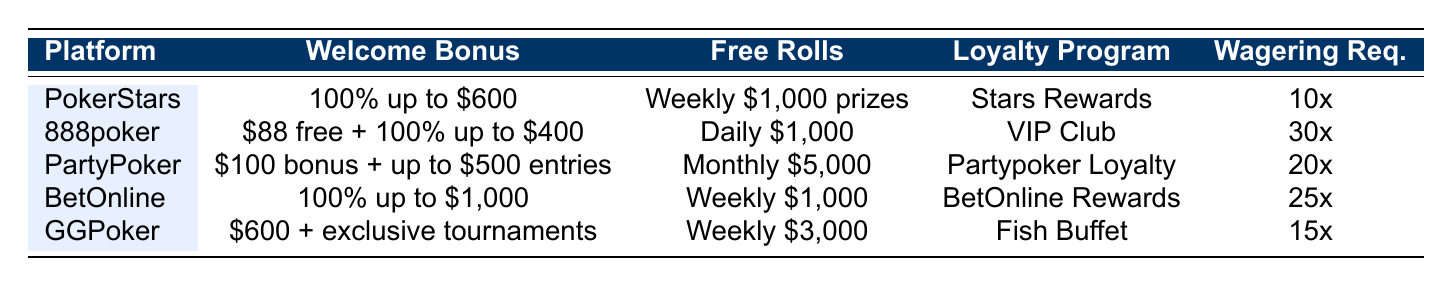What is the welcome bonus offered by GGPoker? The table states that GGPoker offers a welcome bonus of "$600 + exclusive tournaments."
Answer: $600 + exclusive tournaments Which platform has the lowest wagering requirement? By comparing the wagering requirements in the table, PokerStars has the lowest at "10x."
Answer: PokerStars Does PartyPoker offer daily free rolls? The table indicates that PartyPoker offers a "Monthly $5,000 tournament" for free rolls, meaning it does not provide daily free rolls.
Answer: No What is the total potential welcome bonus of 888poker? The welcome bonus for 888poker consists of "$88 free upon registration + 100% up to $400," which sums up to $488 as the maximum total bonus upon deposit.
Answer: $488 Which platform has the best loyalty program according to the naming? The table lists several loyalty programs, but it does not quantify their value or performance. However, the unique name "Fish Buffet" for GGPoker might imply an appealing offer.
Answer: GGPoker What is the maximum bonus amount you can receive from BetOnline? The welcome bonus from BetOnline is articulated as "100% up to $1,000," indicating the maximum bonus is $1,000 if the initial deposit matches that amount.
Answer: $1,000 How do the free roll offers compare between 888poker and GGPoker? Looking at the table, 888poker provides "$1,000 daily free rolls," while GGPoker offers "$3,000 weekly free rolls." Converting these into a daily context for comparison, GGPoker's offering would average approximately $428 per day, making 888poker's offer higher.
Answer: 888poker has higher daily offers Are there any platforms that offer cashback or loss incentives? According to the table, GGPoker specifies "Cashback on losses" as part of its promotions, indicating it does offer such incentives.
Answer: Yes, GGPoker What is the common expiration period for bonuses among these platforms? Analyzing the expiration periods from the table, PokerStars and BetOnline both have "60 days," while the others have either 30 or 90 days, making 60 days a common duration for some.
Answer: 60 days is common (PokerStars & BetOnline) If I want to participate in daily free rolls, which platform should I choose? Since only 888poker provides "Daily $1,000 free rolls," it would be the recommended option for daily participation.
Answer: 888poker 